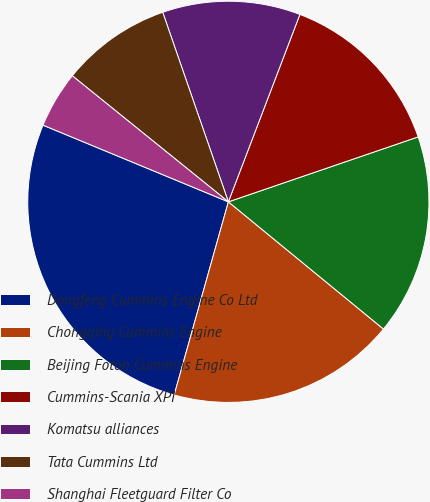Convert chart to OTSL. <chart><loc_0><loc_0><loc_500><loc_500><pie_chart><fcel>Dongfeng Cummins Engine Co Ltd<fcel>Chongqing Cummins Engine<fcel>Beijing Foton Cummins Engine<fcel>Cummins-Scania XPI<fcel>Komatsu alliances<fcel>Tata Cummins Ltd<fcel>Shanghai Fleetguard Filter Co<nl><fcel>26.89%<fcel>18.42%<fcel>16.18%<fcel>13.95%<fcel>11.11%<fcel>8.88%<fcel>4.57%<nl></chart> 